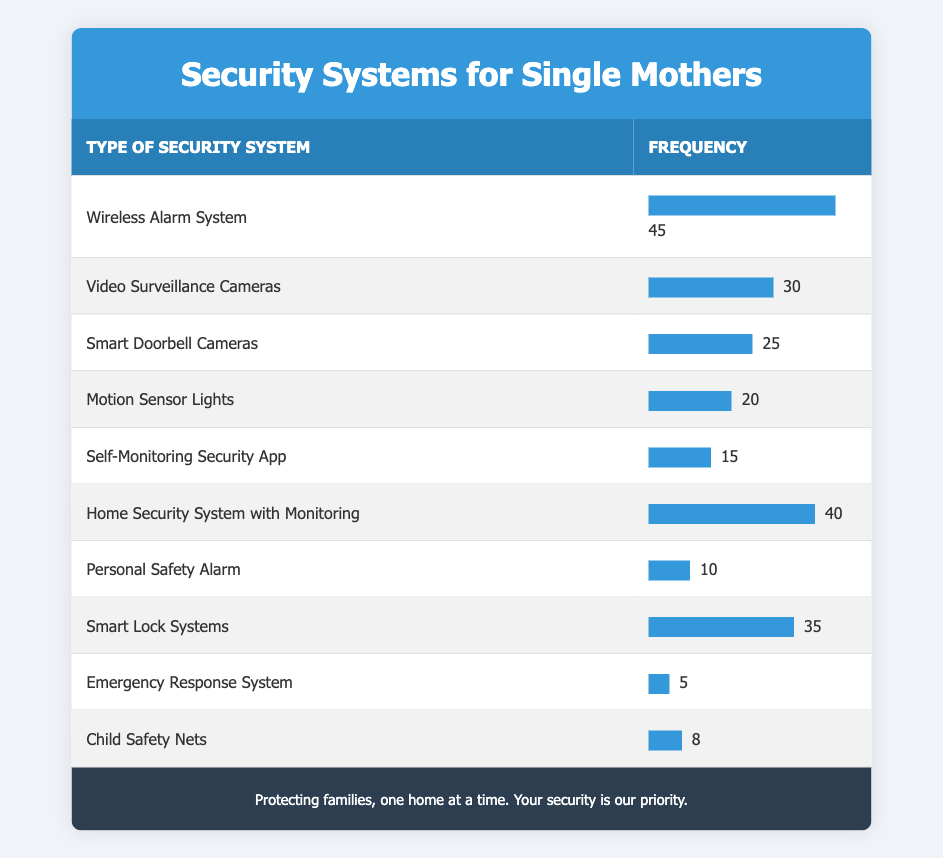What is the most purchased security system type among single mothers? The highest frequency listed in the table is 45, corresponding to the "Wireless Alarm System". This means it is the most purchased by single mothers.
Answer: Wireless Alarm System What is the frequency of the "Personal Safety Alarm"? The table shows that the "Personal Safety Alarm" has a frequency of 10. This is a specific value directly available in the table.
Answer: 10 What are the total frequencies of security systems that fall under video surveillance? The table lists "Video Surveillance Cameras" with a frequency of 30. The other category is "Smart Doorbell Cameras," which has a frequency of 25. Adding these frequencies gives 30 + 25 = 55.
Answer: 55 Is the frequency of "Emergency Response System" greater than that of "Smart Lock Systems"? The frequency of "Emergency Response System" is 5, while "Smart Lock Systems" has a frequency of 35. Since 5 is not greater than 35, the answer is no.
Answer: No What is the average frequency of the top three purchased security systems? The top three purchased systems are "Wireless Alarm System" (45), "Home Security System with Monitoring" (40), and "Smart Lock Systems" (35). Adding these frequencies gives 45 + 40 + 35 = 120. To find the average, divide by 3: 120 / 3 = 40.
Answer: 40 How many more purchases were made for "Motion Sensor Lights" compared to "Personal Safety Alarm"? "Motion Sensor Lights" has a frequency of 20, and "Personal Safety Alarm" has a frequency of 10. The difference is 20 - 10 = 10, so there were 10 more purchases of "Motion Sensor Lights".
Answer: 10 Which security system had the least number of purchases? The "Emergency Response System" has the least frequency in the table, with a frequency of 5. It's the lowest value compared to all other systems listed.
Answer: Emergency Response System What is the combined frequency of "Self-Monitoring Security App" and "Child Safety Nets"? The frequency of "Self-Monitoring Security App" is 15, and "Child Safety Nets" is 8. Adding these values gives 15 + 8 = 23.
Answer: 23 Are there more purchases for "Smart Doorbell Cameras" than for "Motion Sensor Lights"? The frequency of "Smart Doorbell Cameras" is 25, while "Motion Sensor Lights" has 20. Since 25 is greater than 20, the answer is yes.
Answer: Yes 